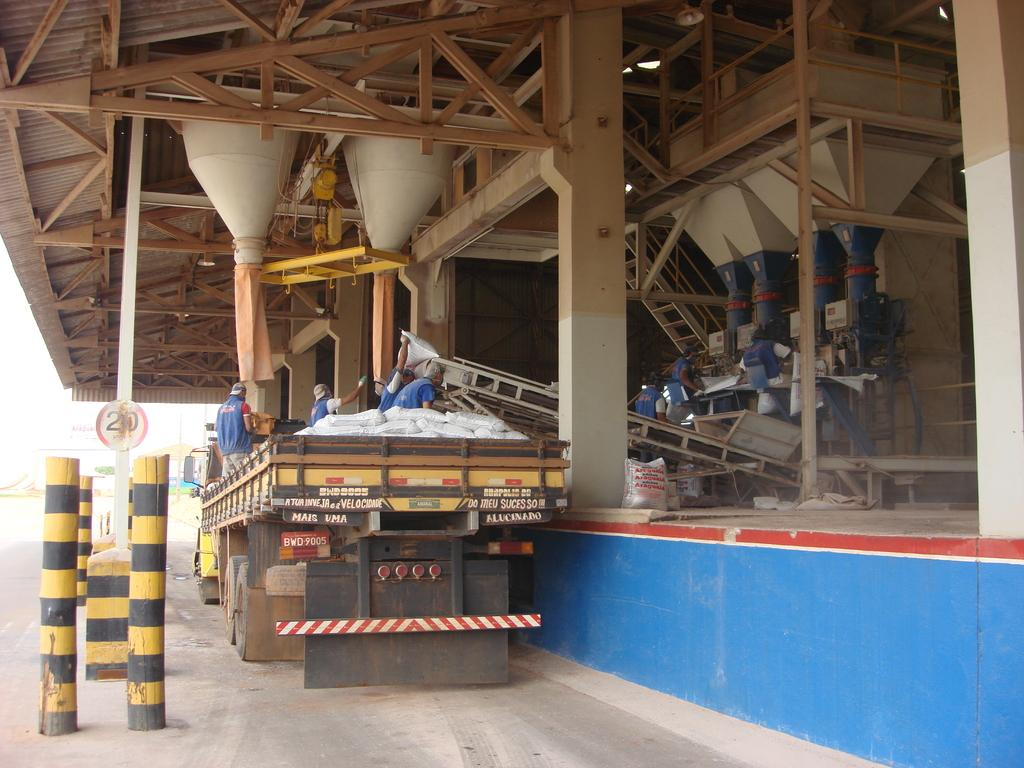What is the main subject of the image? There is a vehicle in the image. Who or what is inside the vehicle? There is a group of people in the vehicle. What can be seen in the background of the image? There are poles in the background of the image. What is the color of the sky in the image? The sky is visible in the image, and it appears to be white in color. What type of bait is being used to catch fish in the image? There is no mention of fishing or bait in the image; it features a vehicle with people inside and poles in the background. What language are the people in the vehicle speaking? The image does not provide any information about the language being spoken by the people in the vehicle. 